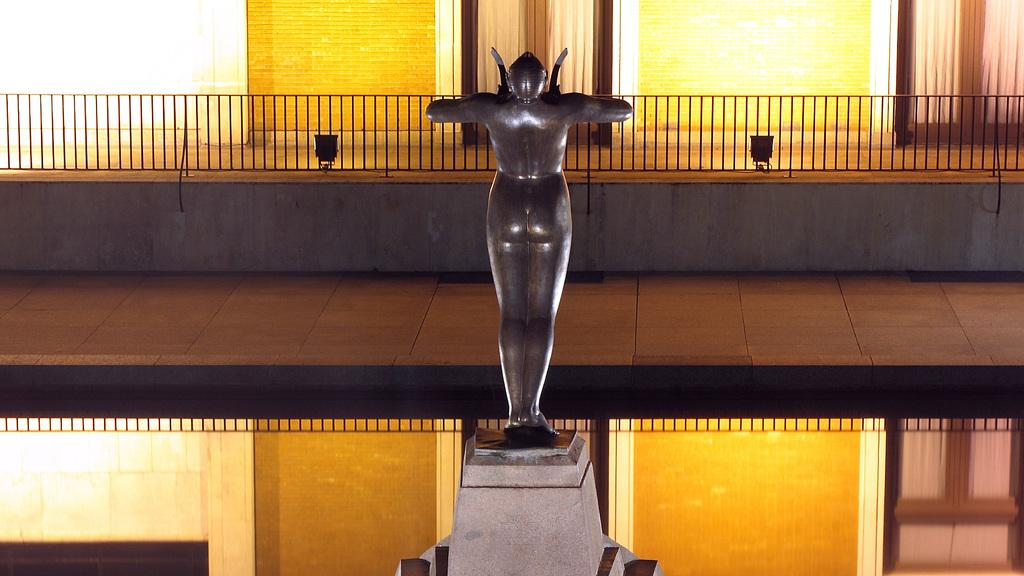What type of structure is present in the image? There is a building in the image. What additional feature can be seen near the building? There is a statue in the image. What can be seen illuminating the area in the image? Lights are visible in the image. What type of window treatment is present in the image? There are blinds on the windows in the image. What type of support can be seen for the statue in the image? There is no visible support for the statue in the image. Can you tell me how many teeth the statue has in the image? The statue does not have teeth, as it is not a living being. 